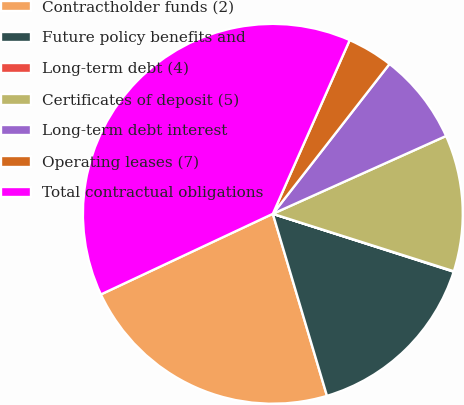<chart> <loc_0><loc_0><loc_500><loc_500><pie_chart><fcel>Contractholder funds (2)<fcel>Future policy benefits and<fcel>Long-term debt (4)<fcel>Certificates of deposit (5)<fcel>Long-term debt interest<fcel>Operating leases (7)<fcel>Total contractual obligations<nl><fcel>22.62%<fcel>15.47%<fcel>0.04%<fcel>11.61%<fcel>7.75%<fcel>3.9%<fcel>38.61%<nl></chart> 